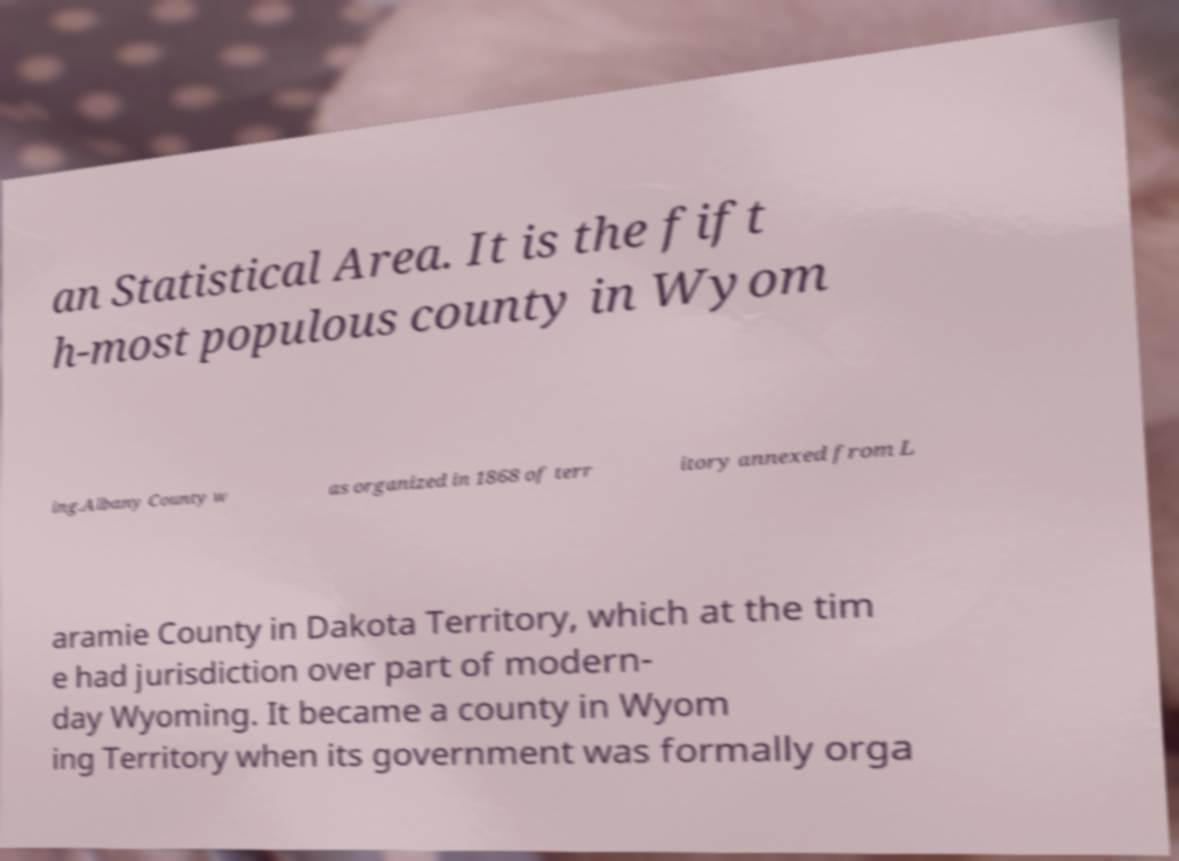Can you accurately transcribe the text from the provided image for me? an Statistical Area. It is the fift h-most populous county in Wyom ing.Albany County w as organized in 1868 of terr itory annexed from L aramie County in Dakota Territory, which at the tim e had jurisdiction over part of modern- day Wyoming. It became a county in Wyom ing Territory when its government was formally orga 